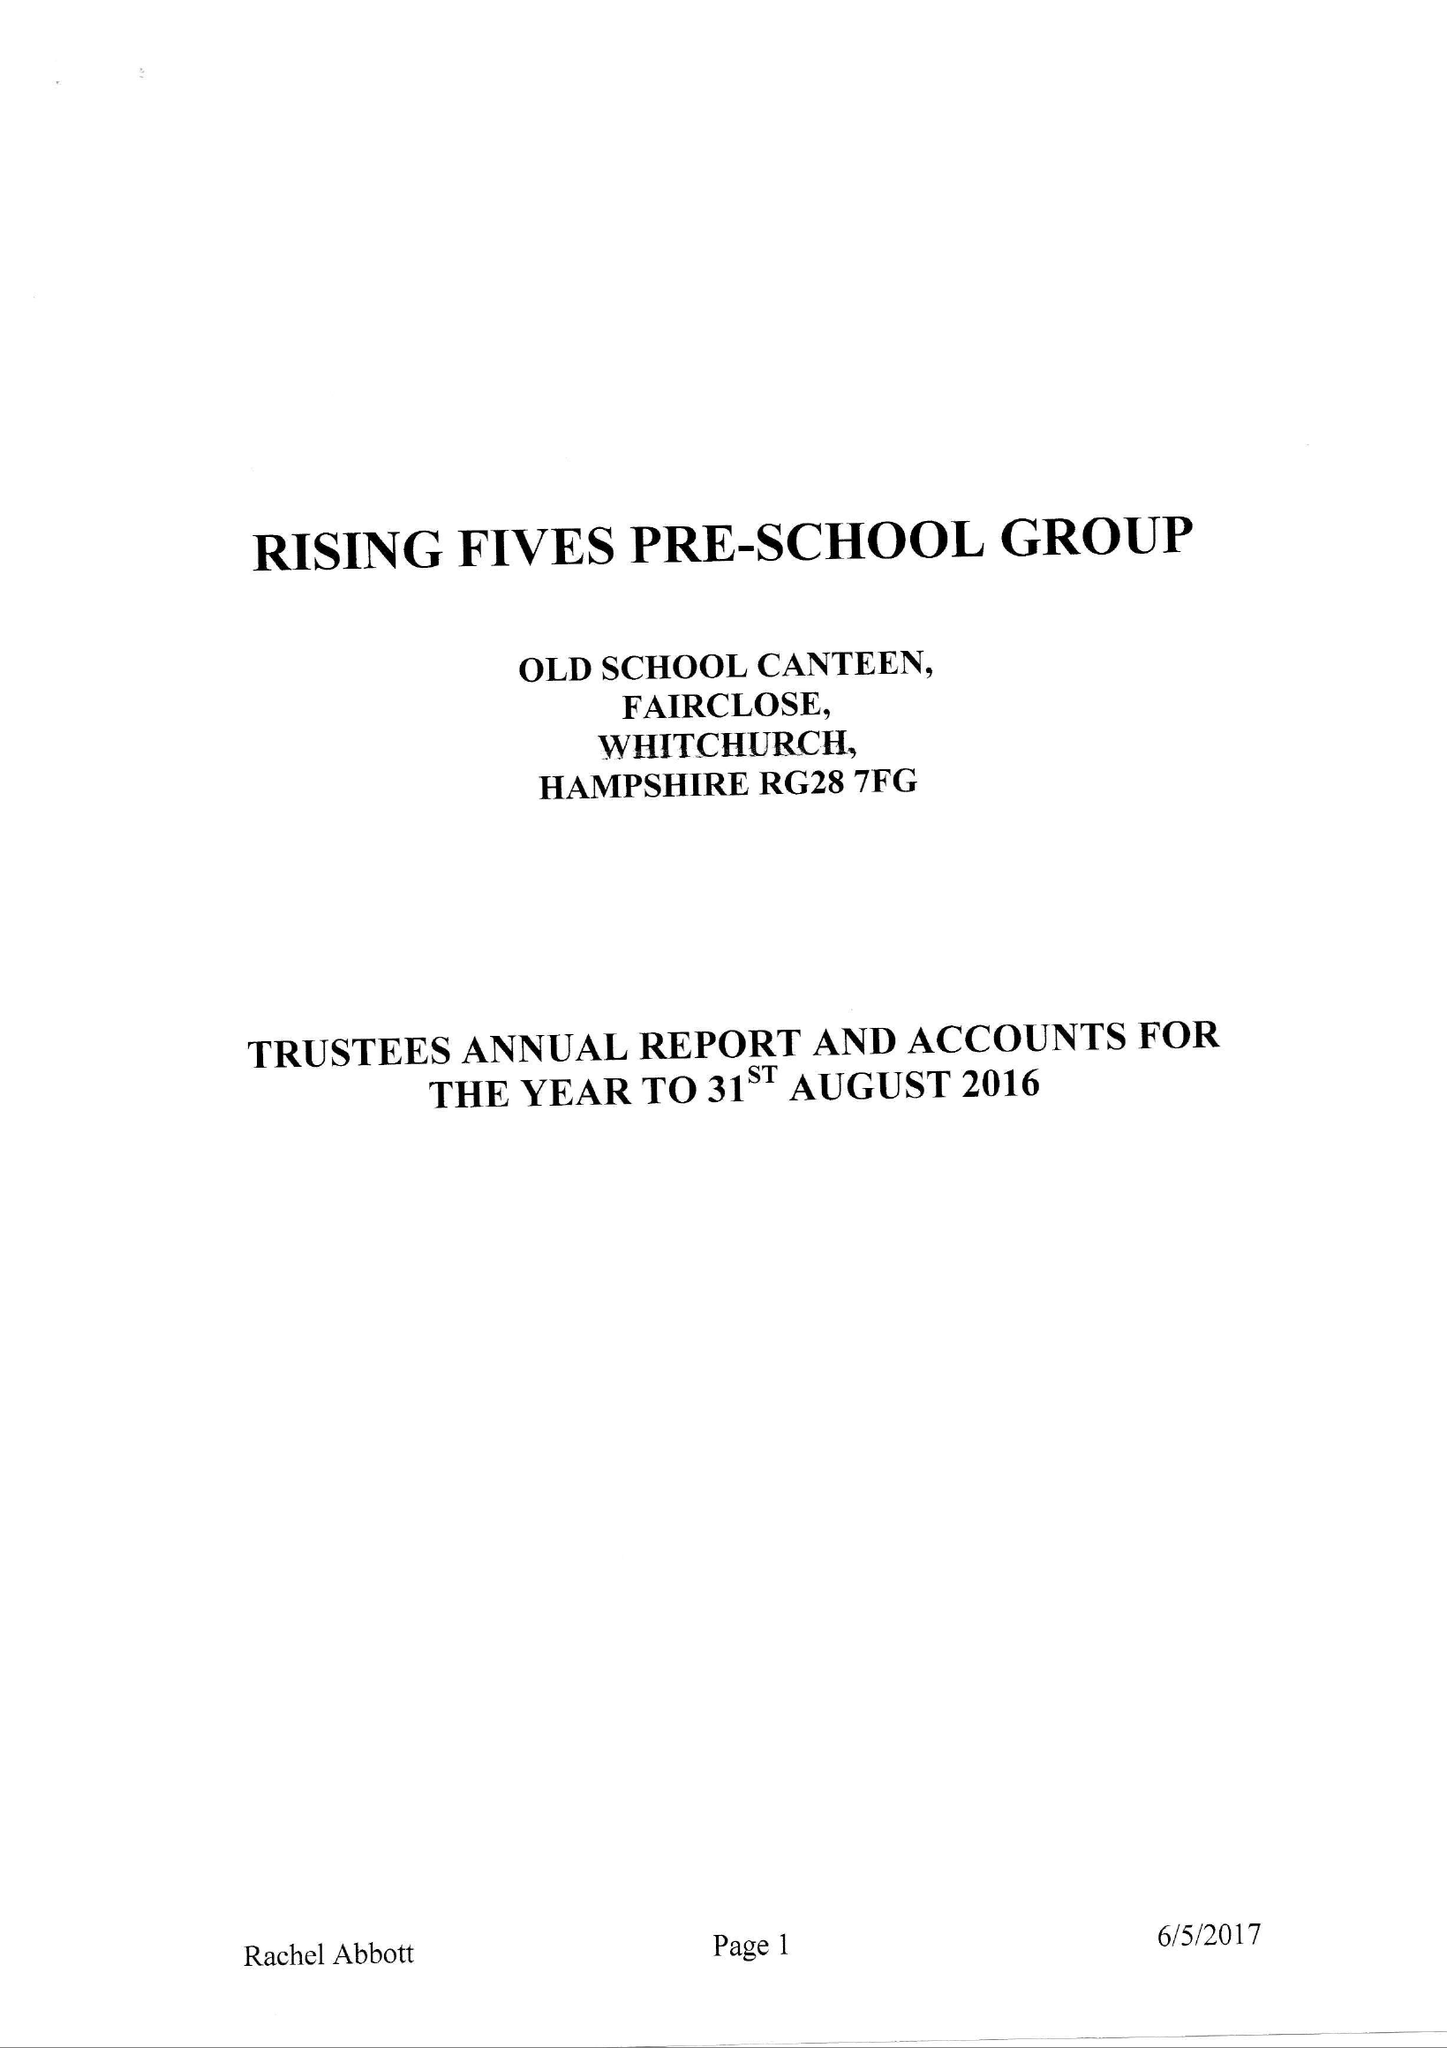What is the value for the address__post_town?
Answer the question using a single word or phrase. WHITCHURCH 